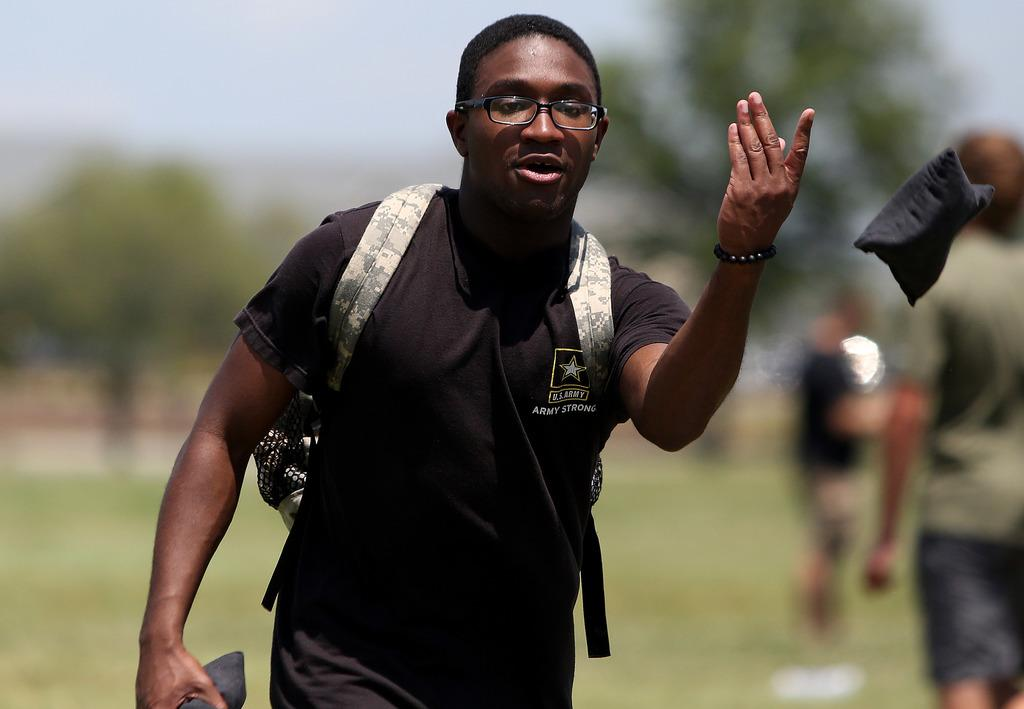What is the person in the image carrying on their back? The person in the image is carrying a backpack. How many people are on the right side of the image? There are two persons on the right side of the image. What can be seen in the air in the image? There is a black object in the air in the image. Can you describe the background of the image? The background of the image is blurred. What type of rat can be seen wearing a mitten in the image? There is no rat or mitten present in the image. How many needles are visible in the image? There are no needles visible in the image. 